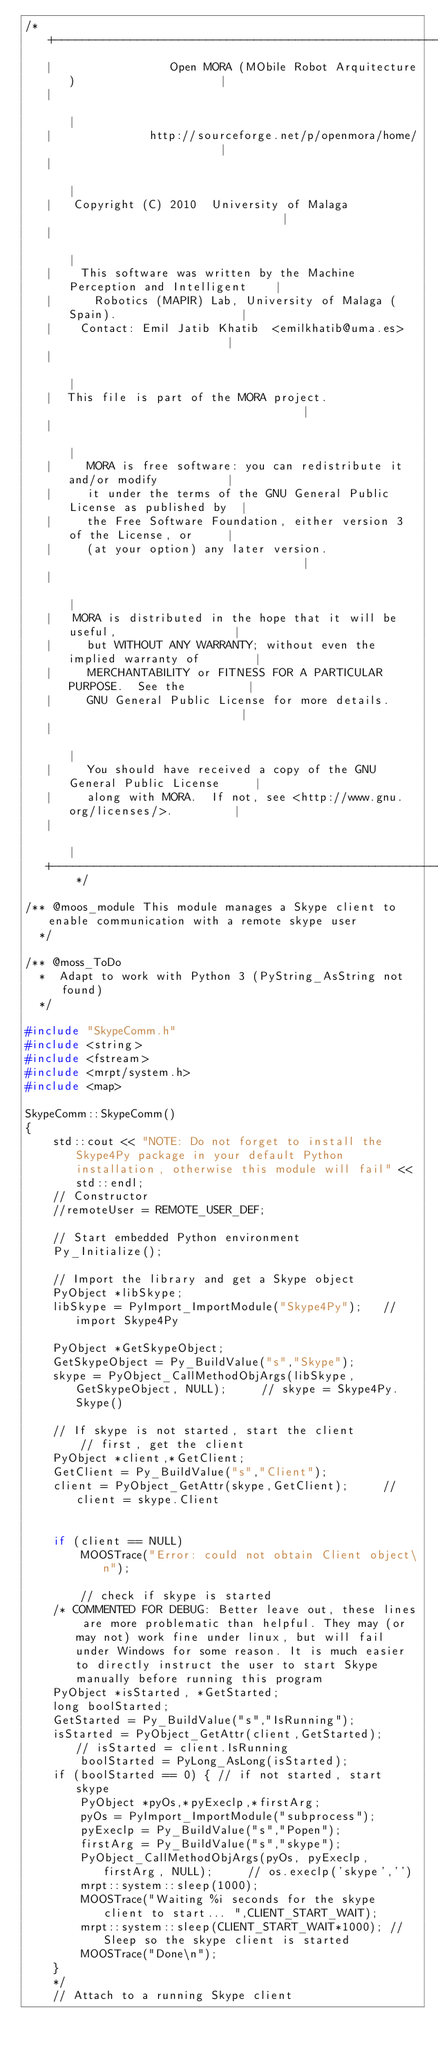<code> <loc_0><loc_0><loc_500><loc_500><_C++_>/* +---------------------------------------------------------------------------+
   |                 Open MORA (MObile Robot Arquitecture)                     |
   |                                                                           |
   |              http://sourceforge.net/p/openmora/home/                      |
   |                                                                           |
   |   Copyright (C) 2010  University of Malaga                                |
   |                                                                           |
   |    This software was written by the Machine Perception and Intelligent    |
   |      Robotics (MAPIR) Lab, University of Malaga (Spain).                  |
   |    Contact: Emil Jatib Khatib  <emilkhatib@uma.es>                        |
   |                                                                           |
   |  This file is part of the MORA project.                                   |
   |                                                                           |
   |     MORA is free software: you can redistribute it and/or modify          |
   |     it under the terms of the GNU General Public License as published by  |
   |     the Free Software Foundation, either version 3 of the License, or     |
   |     (at your option) any later version.                                   |
   |                                                                           |
   |   MORA is distributed in the hope that it will be useful,                 |
   |     but WITHOUT ANY WARRANTY; without even the implied warranty of        |
   |     MERCHANTABILITY or FITNESS FOR A PARTICULAR PURPOSE.  See the         |
   |     GNU General Public License for more details.                          |
   |                                                                           |
   |     You should have received a copy of the GNU General Public License     |
   |     along with MORA.  If not, see <http://www.gnu.org/licenses/>.         |
   |                                                                           |
   +---------------------------------------------------------------------------+ */

/** @moos_module This module manages a Skype client to enable communication with a remote skype user    
  */

/** @moss_ToDo
  *  Adapt to work with Python 3 (PyString_AsString not found)
  */

#include "SkypeComm.h"
#include <string>
#include <fstream>
#include <mrpt/system.h>
#include <map>

SkypeComm::SkypeComm()
{
	std::cout << "NOTE: Do not forget to install the Skype4Py package in your default Python installation, otherwise this module will fail" << std::endl;
    // Constructor
    //remoteUser = REMOTE_USER_DEF;

    // Start embedded Python environment
    Py_Initialize();

    // Import the library and get a Skype object
    PyObject *libSkype;
    libSkype = PyImport_ImportModule("Skype4Py");   // import Skype4Py

    PyObject *GetSkypeObject;
    GetSkypeObject = Py_BuildValue("s","Skype");
    skype = PyObject_CallMethodObjArgs(libSkype, GetSkypeObject, NULL);     // skype = Skype4Py.Skype()

    // If skype is not started, start the client
        // first, get the client
    PyObject *client,*GetClient;
    GetClient = Py_BuildValue("s","Client");
    client = PyObject_GetAttr(skype,GetClient);     // client = skype.Client


	if (client == NULL)
		MOOSTrace("Error: could not obtain Client object\n");

        // check if skype is started
	/* COMMENTED FOR DEBUG: Better leave out, these lines are more problematic than helpful. They may (or may not) work fine under linux, but will fail under Windows for some reason. It is much easier to directly instruct the user to start Skype manually before running this program
    PyObject *isStarted, *GetStarted;
    long boolStarted;
    GetStarted = Py_BuildValue("s","IsRunning");
    isStarted = PyObject_GetAttr(client,GetStarted);    // isStarted = client.IsRunning
	    boolStarted = PyLong_AsLong(isStarted);
    if (boolStarted == 0) { // if not started, start skype
        PyObject *pyOs,*pyExeclp,*firstArg;
        pyOs = PyImport_ImportModule("subprocess");
        pyExeclp = Py_BuildValue("s","Popen");
        firstArg = Py_BuildValue("s","skype");
        PyObject_CallMethodObjArgs(pyOs, pyExeclp, firstArg, NULL);     // os.execlp('skype','')
		mrpt::system::sleep(1000);
        MOOSTrace("Waiting %i seconds for the skype client to start... ",CLIENT_START_WAIT);
		mrpt::system::sleep(CLIENT_START_WAIT*1000); // Sleep so the skype client is started
        MOOSTrace("Done\n");
    }
	*/
    // Attach to a running Skype client</code> 